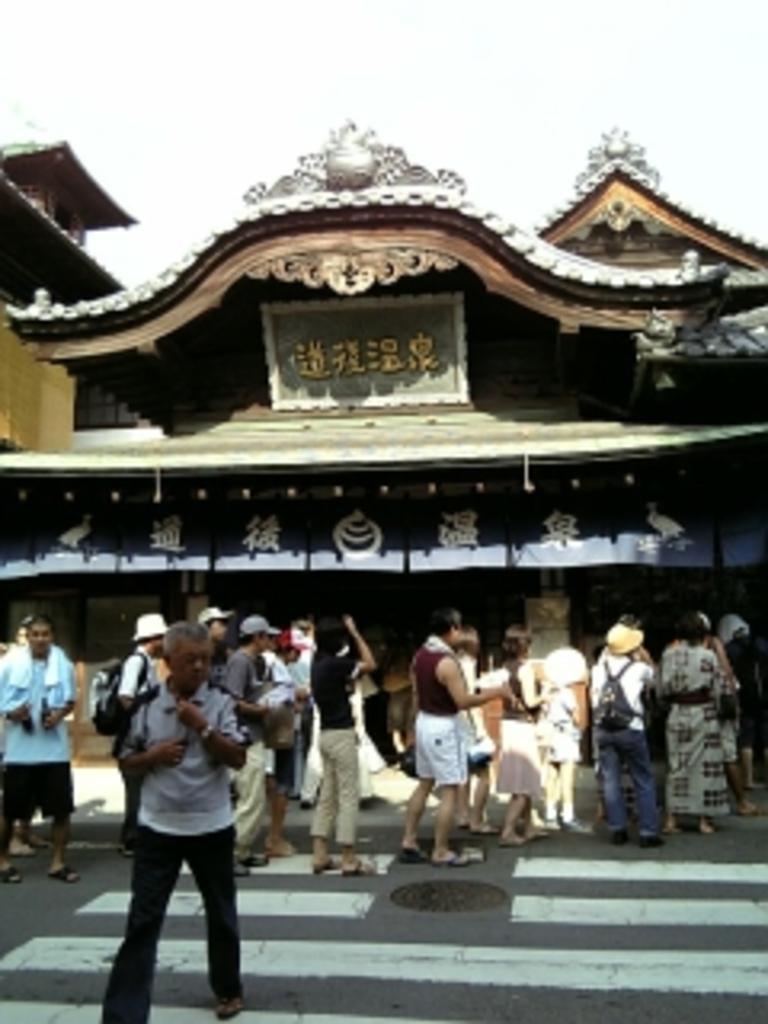Please provide a concise description of this image. In this image it looks like an temple. In front of it there are few people standing on the road in the line. 